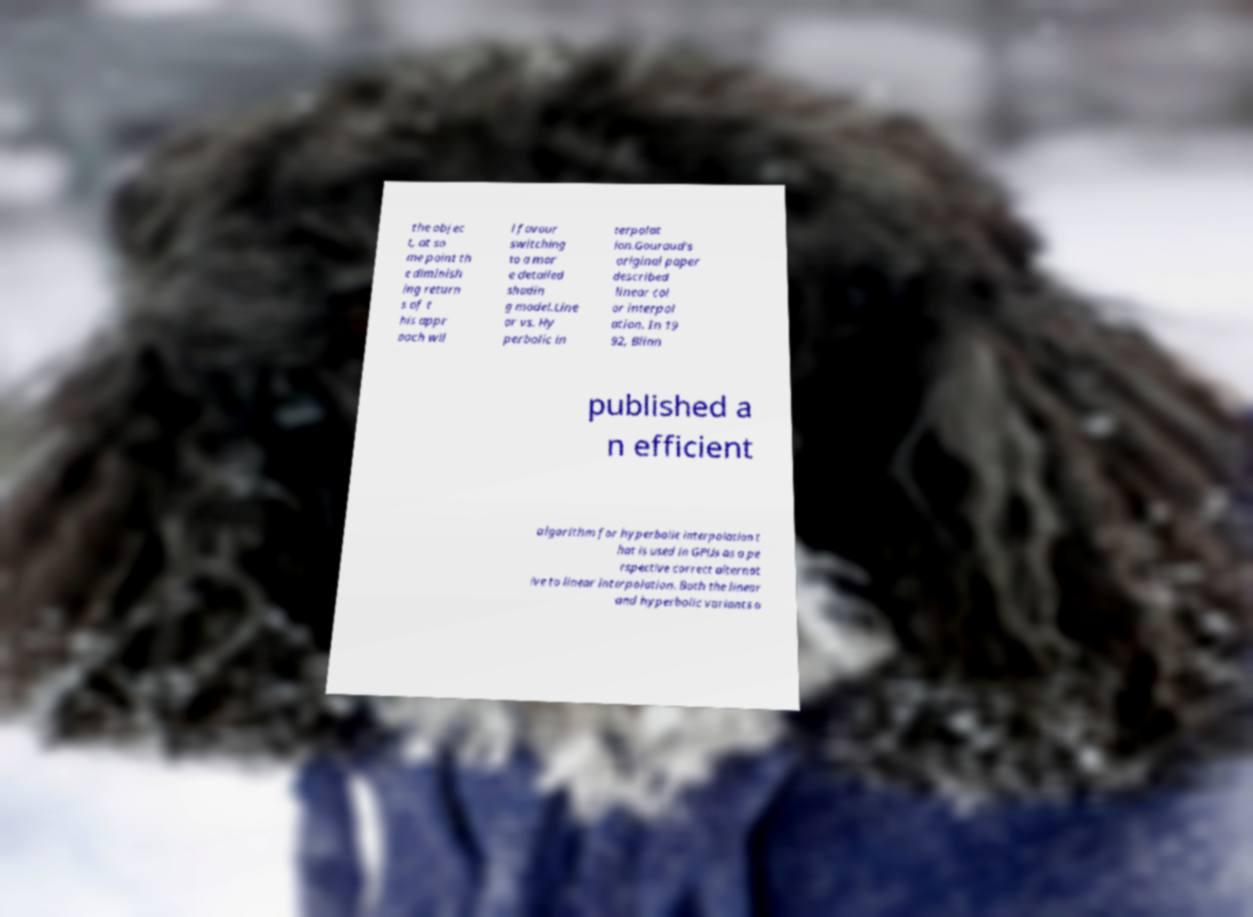Could you assist in decoding the text presented in this image and type it out clearly? the objec t, at so me point th e diminish ing return s of t his appr oach wil l favour switching to a mor e detailed shadin g model.Line ar vs. Hy perbolic in terpolat ion.Gouraud's original paper described linear col or interpol ation. In 19 92, Blinn published a n efficient algorithm for hyperbolic interpolation t hat is used in GPUs as a pe rspective correct alternat ive to linear interpolation. Both the linear and hyperbolic variants o 